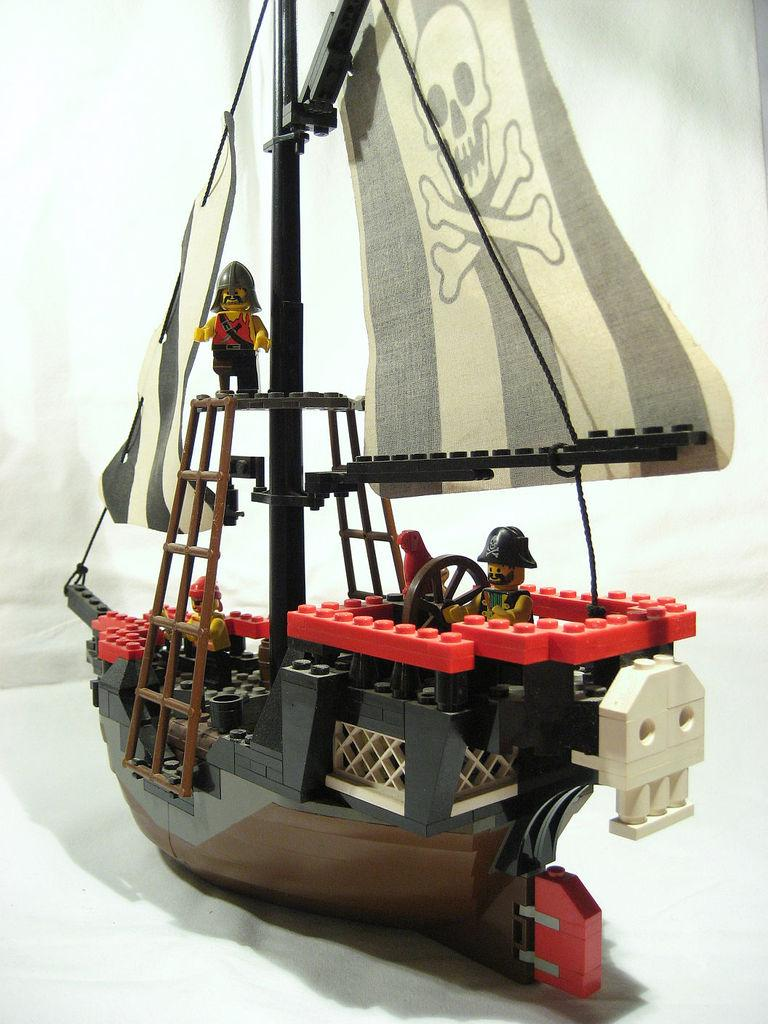What type of puzzle is depicted in the image? The image appears to be a LEGO puzzle. What does the puzzle represent? The puzzle represents a ship. Are there any specific features on the ship? Yes, there are ladders and a steering wheel in the image. How many people are present on the ship? There are three men standing in the image. What is the color of the background in the image? The background of the image is white in color. What type of sweater is the pet wearing in the image? There is no pet or sweater present in the image; it features a LEGO ship puzzle. Can you describe the smile on the pet's face in the image? There is no pet or facial expression present in the image. 